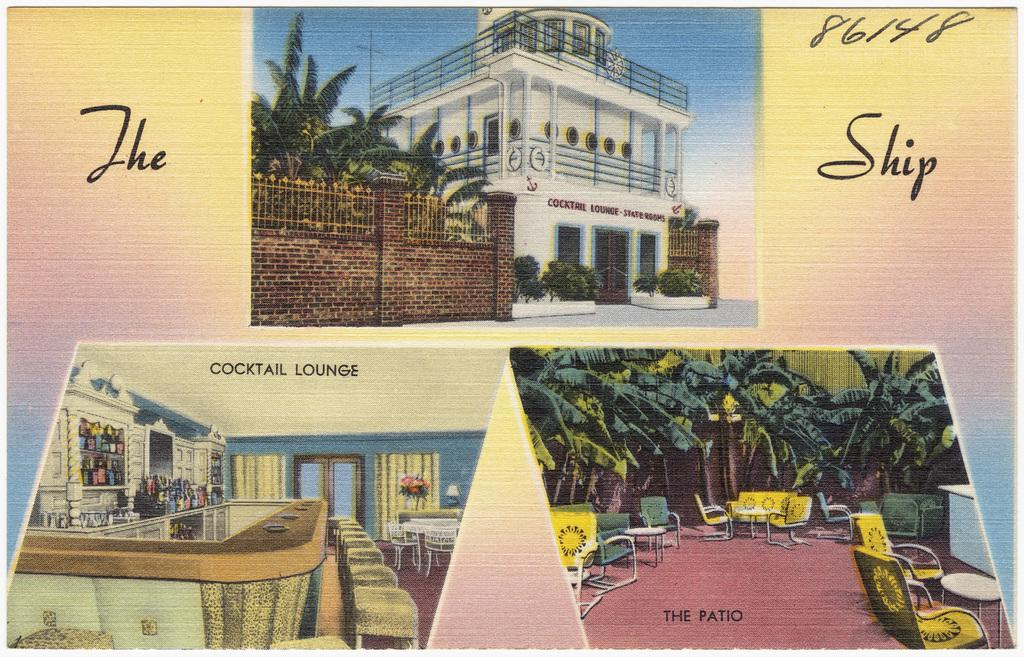What type of furniture can be seen in the image? There are chairs and tables in the image. What type of vegetation is present in the image? There are trees in the image. What type of storage units are visible in the image? There is a cabinet and cupboards in the image. What type of architectural feature is present in the image? There is a wall in the image. What type of structure is visible in the image? There are buildings in the image. What type of barrier is present in the image? There is a fence in the image. What type of text is present in the image? There is text in the image. What part of the natural environment is visible in the image? The sky is visible in the image. What can be inferred about the image based on the provided fact? The image appears to be an edited photo. What type of teeth can be seen in the image? There are no teeth visible in the image. What type of alarm is present in the image? There is no alarm present in the image. 